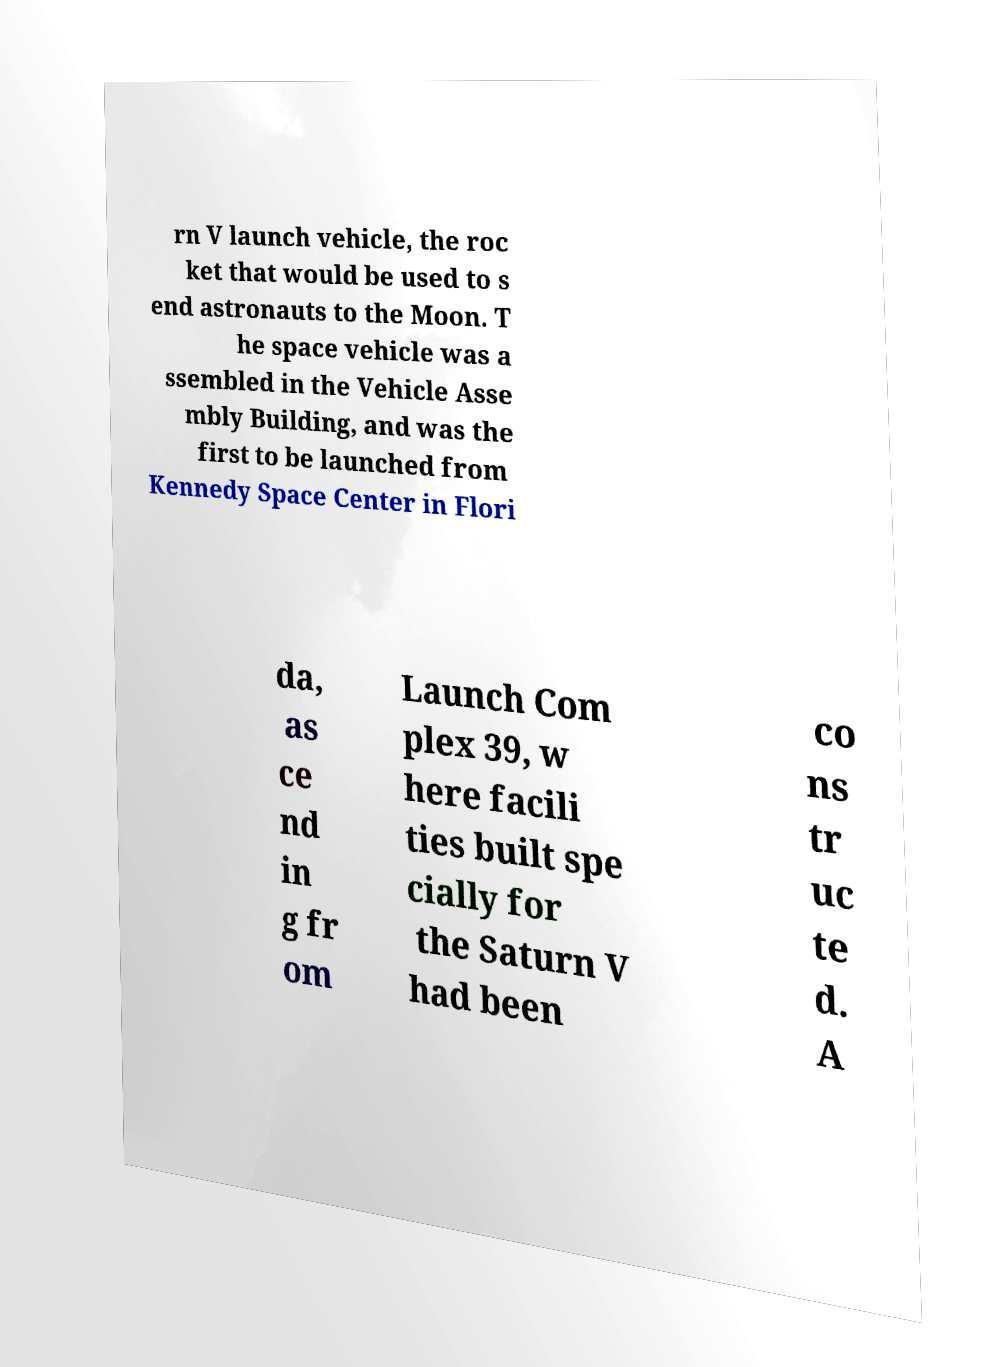What messages or text are displayed in this image? I need them in a readable, typed format. rn V launch vehicle, the roc ket that would be used to s end astronauts to the Moon. T he space vehicle was a ssembled in the Vehicle Asse mbly Building, and was the first to be launched from Kennedy Space Center in Flori da, as ce nd in g fr om Launch Com plex 39, w here facili ties built spe cially for the Saturn V had been co ns tr uc te d. A 